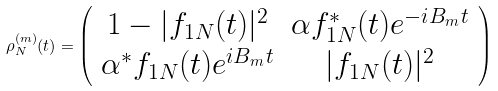<formula> <loc_0><loc_0><loc_500><loc_500>\rho ^ { ( m ) } _ { N } ( t ) = \left ( \begin{array} { c c c c } 1 - | f _ { 1 N } ( t ) | ^ { 2 } & \alpha f _ { 1 N } ^ { * } ( t ) e ^ { - i B _ { m } t } \\ \alpha ^ { * } f _ { 1 N } ( t ) e ^ { i B _ { m } t } & | f _ { 1 N } ( t ) | ^ { 2 } \end{array} \right )</formula> 